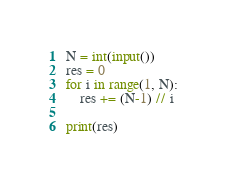Convert code to text. <code><loc_0><loc_0><loc_500><loc_500><_Python_>N = int(input())
res = 0
for i in range(1, N):
    res += (N-1) // i

print(res)</code> 